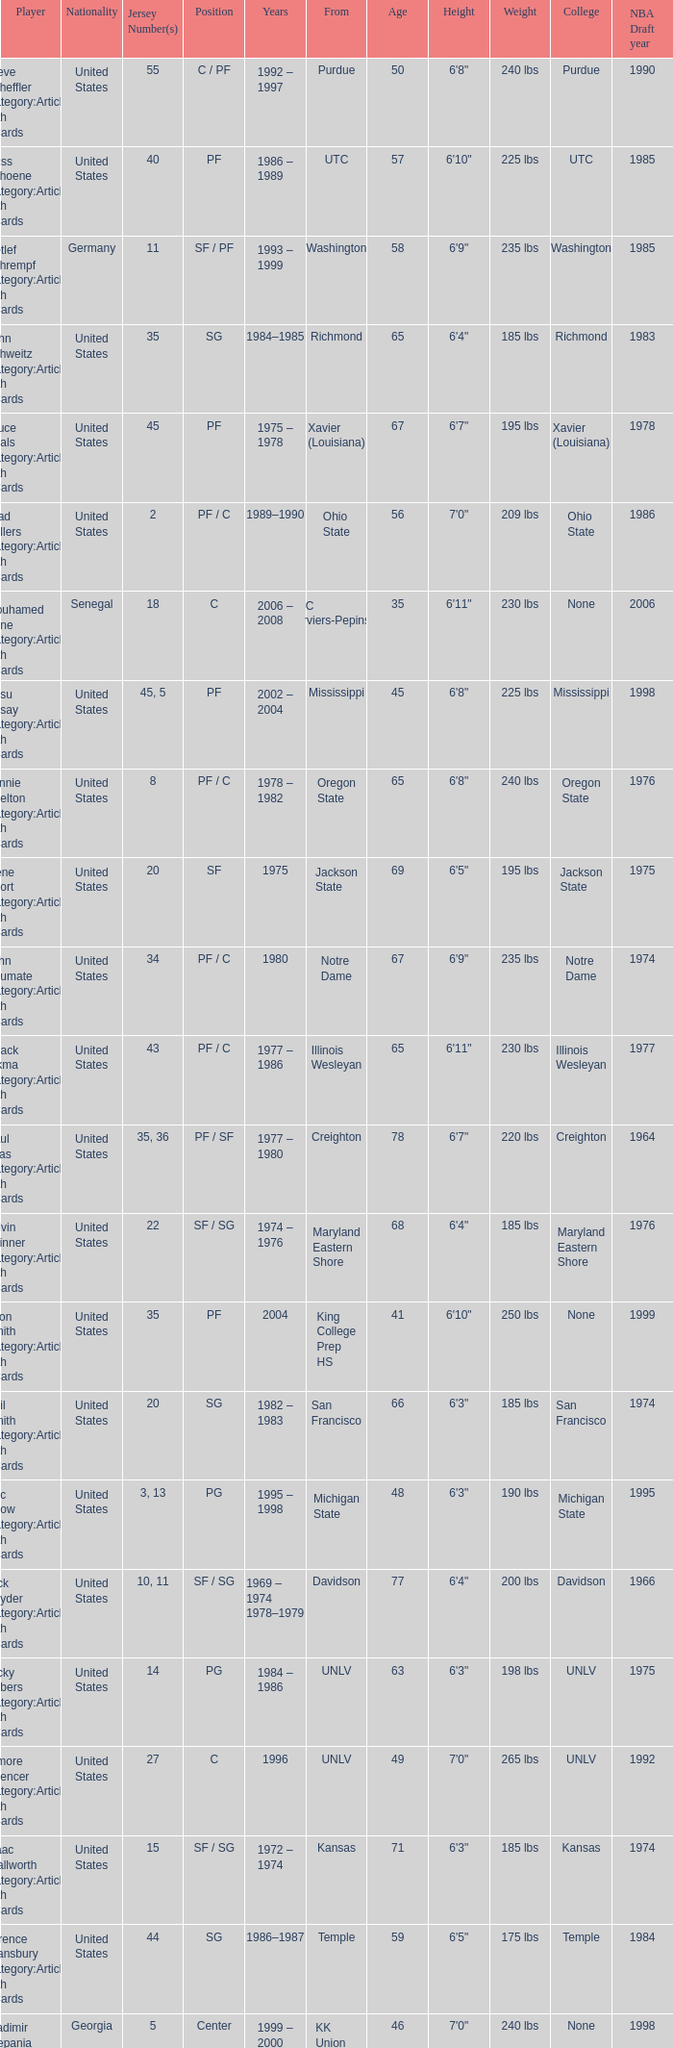What nationality is the player from Oregon State? United States. 